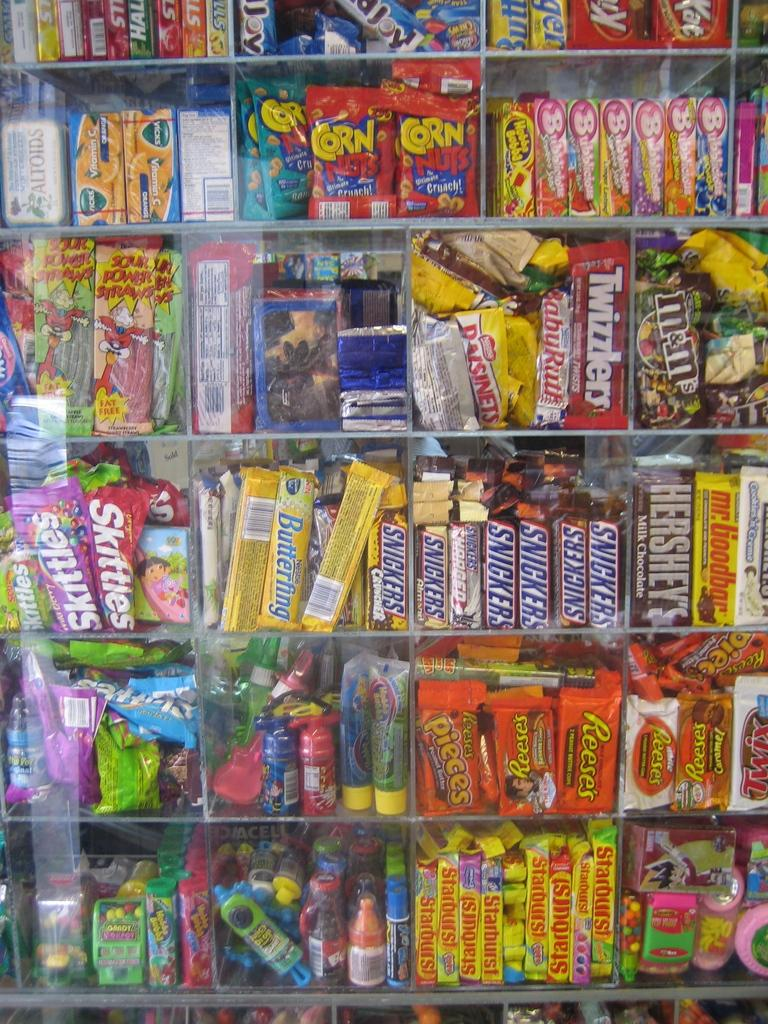Provide a one-sentence caption for the provided image. A candy display with many different kinds including Snickers, Starbursts, Butterfinger, and Skittles. 